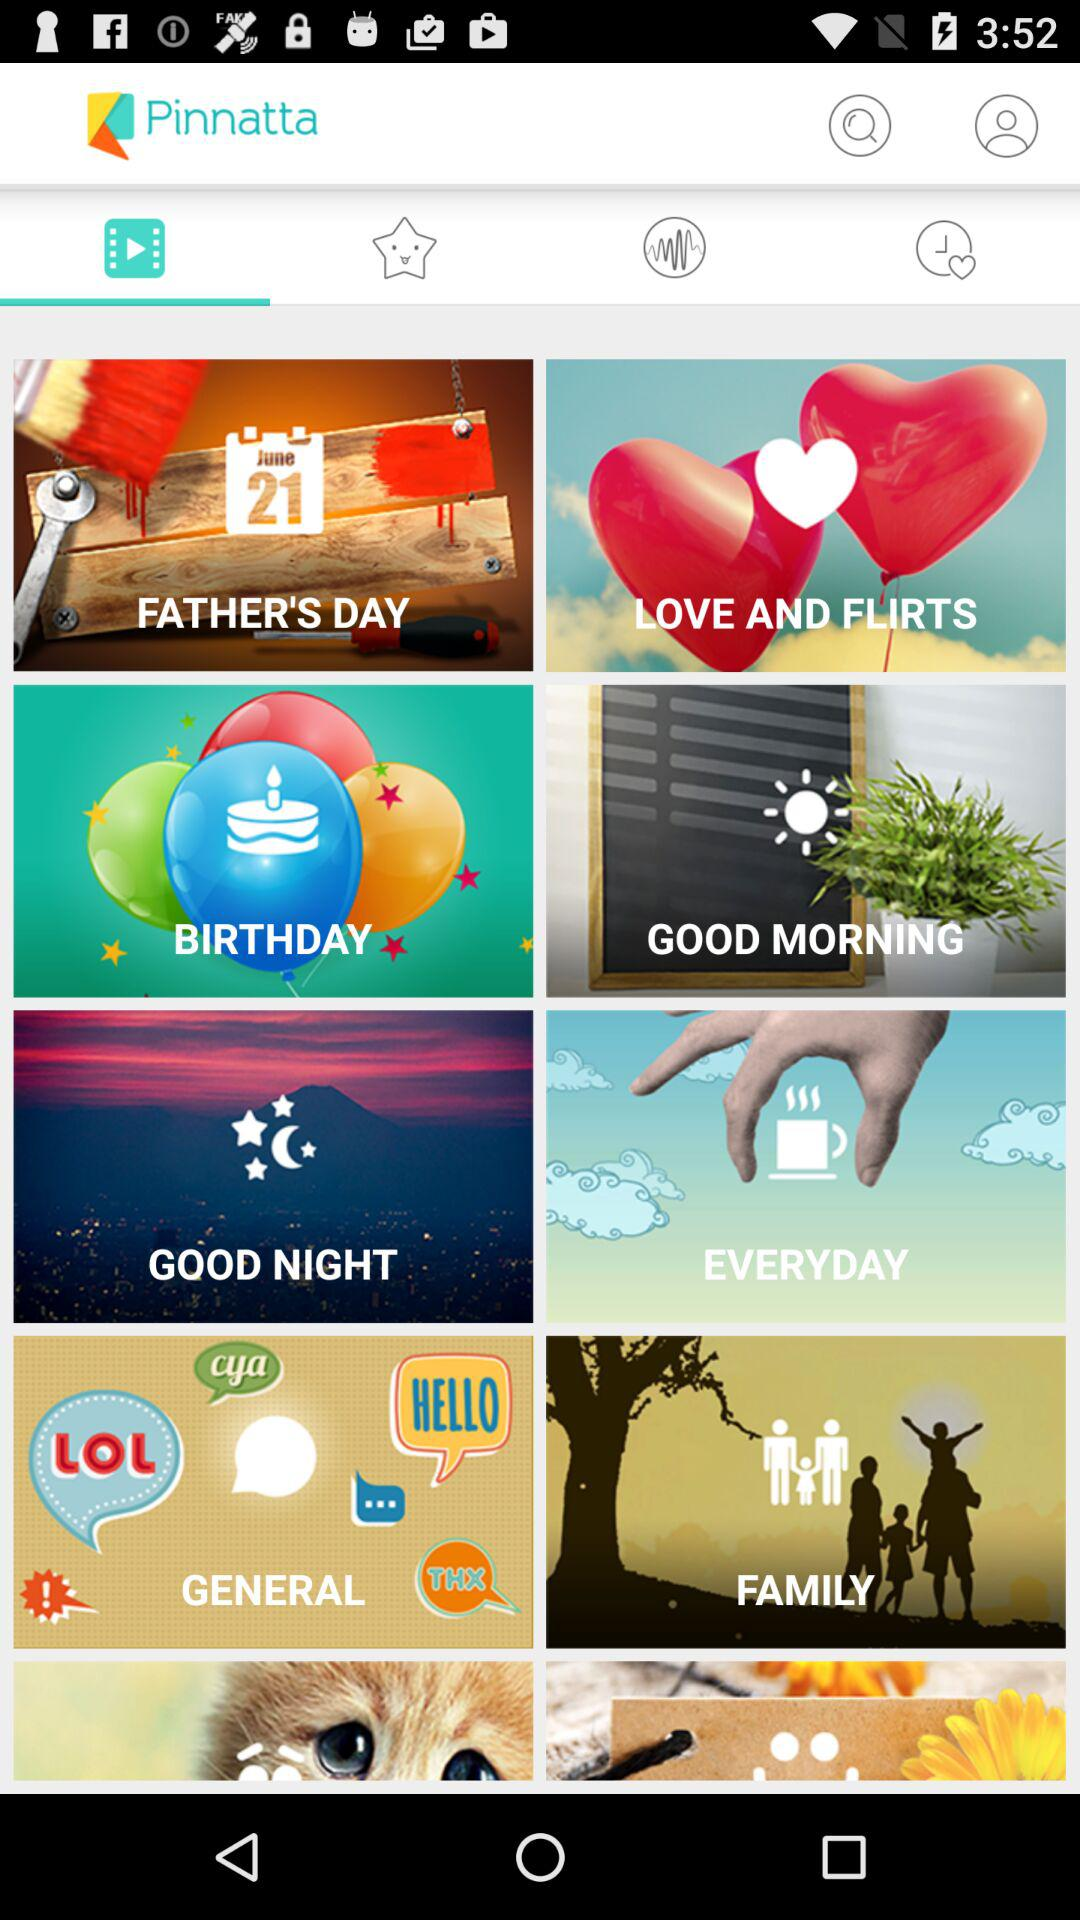On what date is Father's Day? Father's Day is on June 21. 